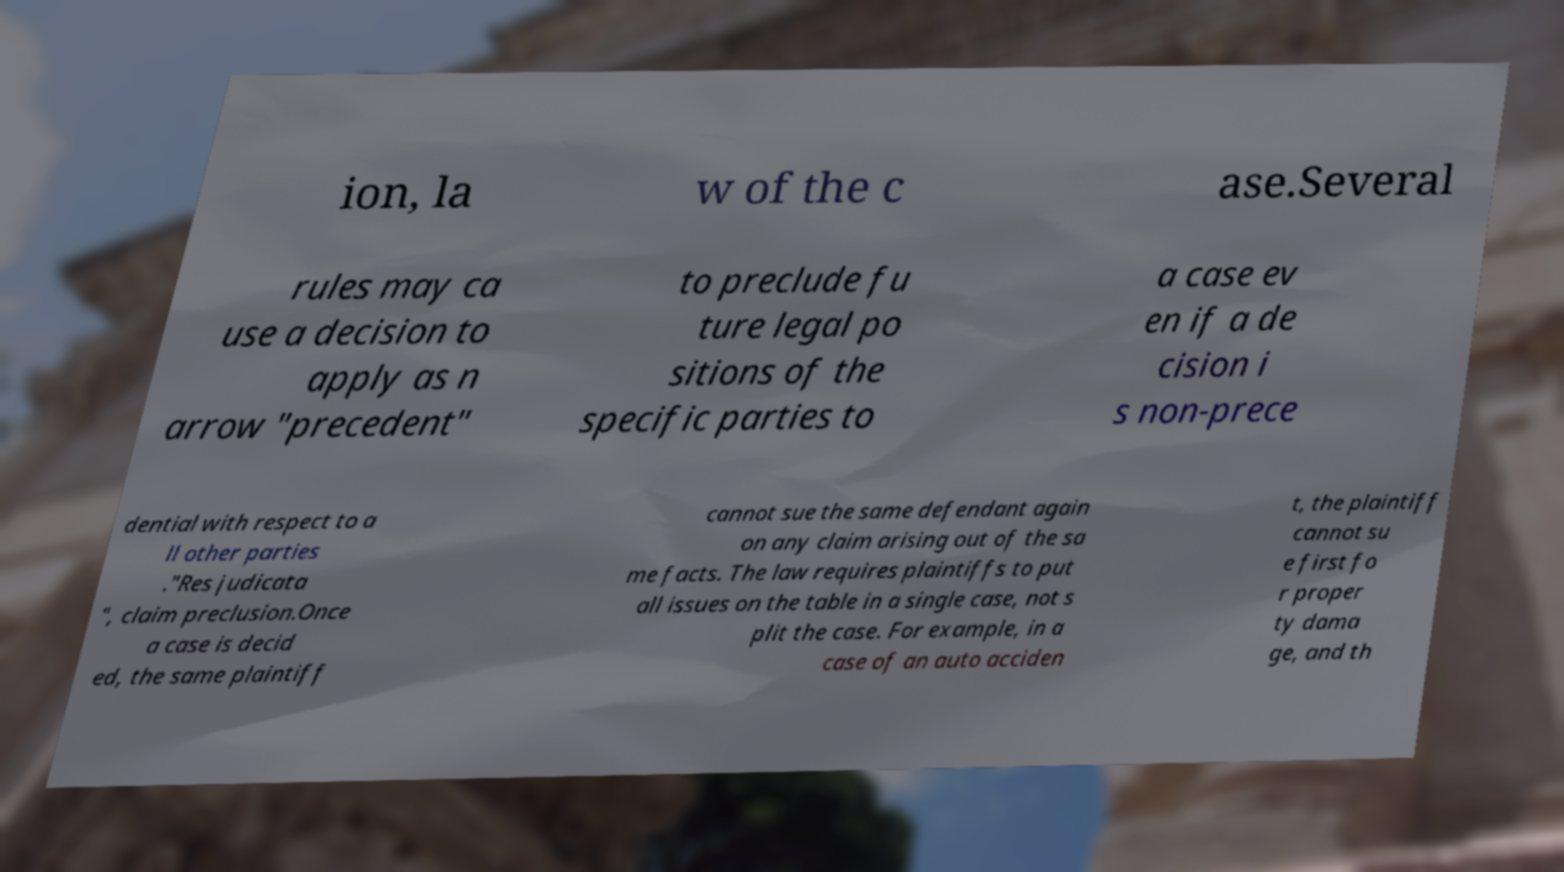Please identify and transcribe the text found in this image. ion, la w of the c ase.Several rules may ca use a decision to apply as n arrow "precedent" to preclude fu ture legal po sitions of the specific parties to a case ev en if a de cision i s non-prece dential with respect to a ll other parties ."Res judicata ", claim preclusion.Once a case is decid ed, the same plaintiff cannot sue the same defendant again on any claim arising out of the sa me facts. The law requires plaintiffs to put all issues on the table in a single case, not s plit the case. For example, in a case of an auto acciden t, the plaintiff cannot su e first fo r proper ty dama ge, and th 